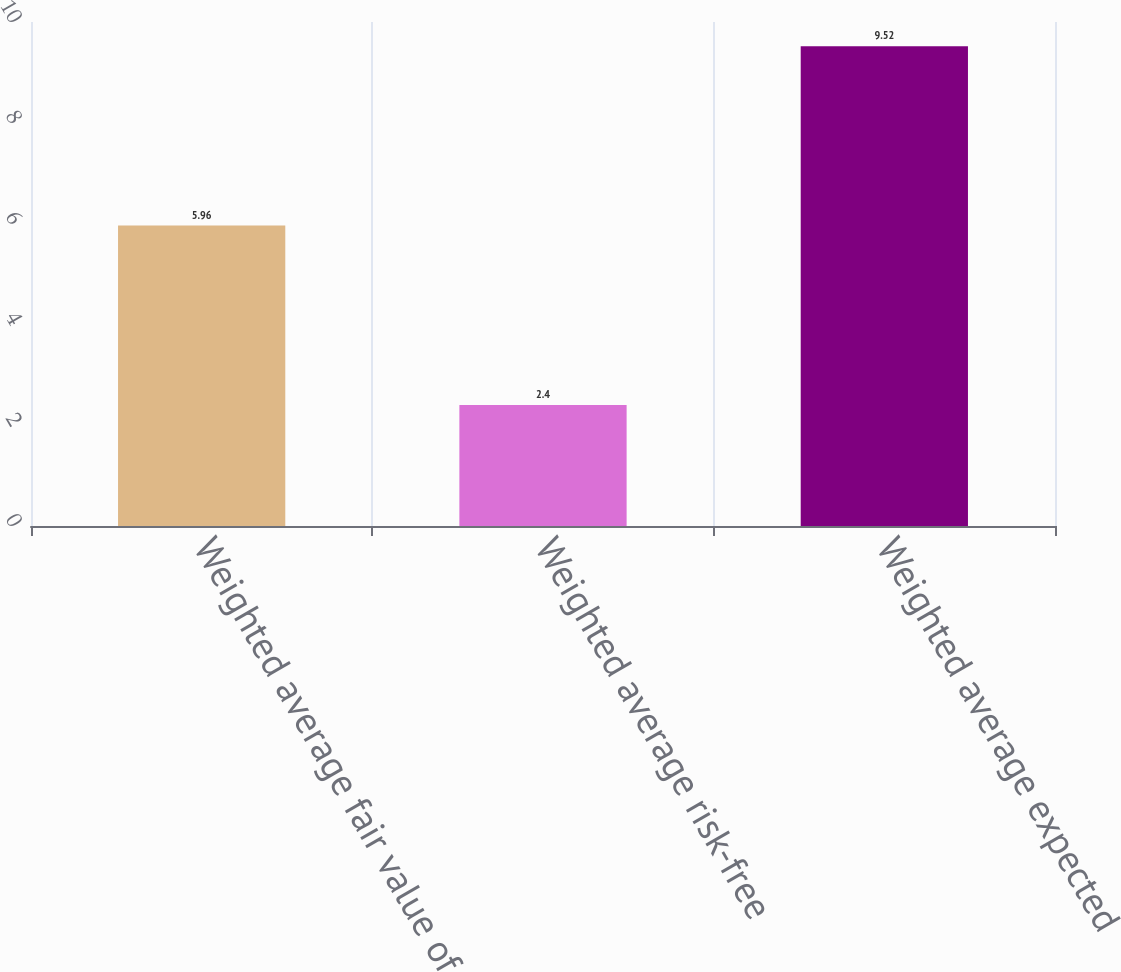Convert chart to OTSL. <chart><loc_0><loc_0><loc_500><loc_500><bar_chart><fcel>Weighted average fair value of<fcel>Weighted average risk-free<fcel>Weighted average expected<nl><fcel>5.96<fcel>2.4<fcel>9.52<nl></chart> 